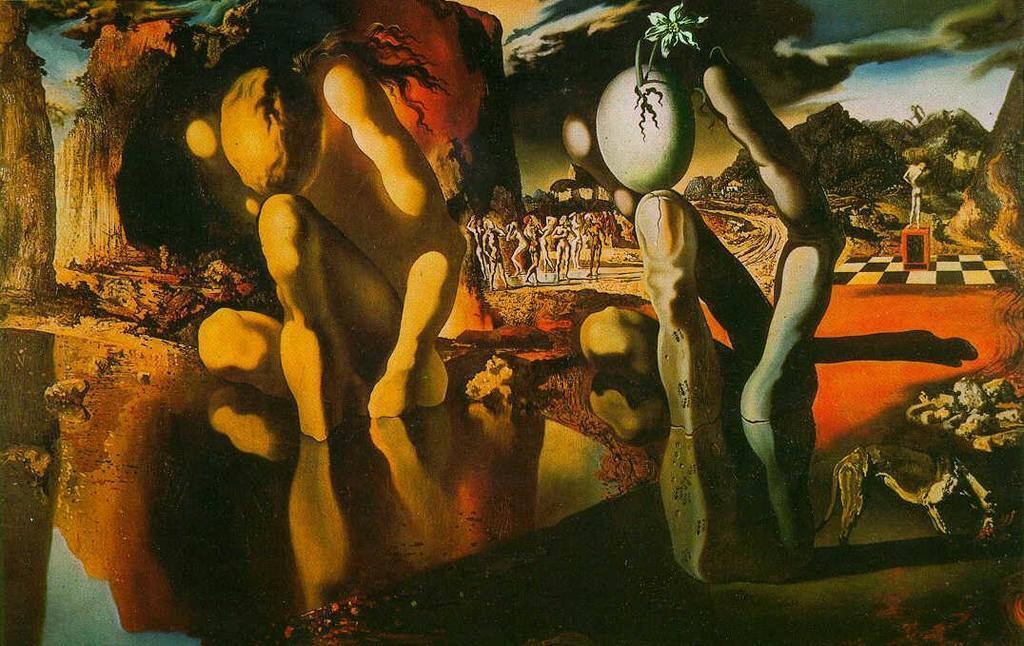Could you give a brief overview of what you see in this image? This is an animation in this image there are some caves, mountains and some other objects. 